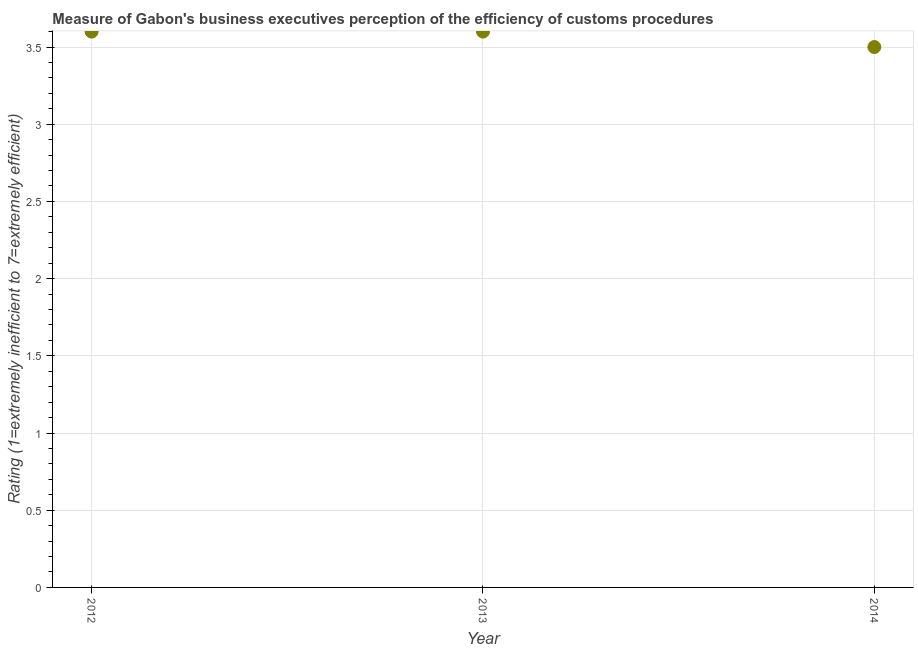Across all years, what is the minimum rating measuring burden of customs procedure?
Keep it short and to the point. 3.5. What is the sum of the rating measuring burden of customs procedure?
Keep it short and to the point. 10.7. What is the difference between the rating measuring burden of customs procedure in 2013 and 2014?
Provide a succinct answer. 0.1. What is the average rating measuring burden of customs procedure per year?
Provide a short and direct response. 3.57. What is the median rating measuring burden of customs procedure?
Give a very brief answer. 3.6. What is the ratio of the rating measuring burden of customs procedure in 2013 to that in 2014?
Your answer should be very brief. 1.03. Is the difference between the rating measuring burden of customs procedure in 2012 and 2014 greater than the difference between any two years?
Your answer should be compact. Yes. What is the difference between the highest and the lowest rating measuring burden of customs procedure?
Make the answer very short. 0.1. In how many years, is the rating measuring burden of customs procedure greater than the average rating measuring burden of customs procedure taken over all years?
Your answer should be compact. 2. Does the rating measuring burden of customs procedure monotonically increase over the years?
Offer a terse response. No. How many dotlines are there?
Offer a very short reply. 1. What is the difference between two consecutive major ticks on the Y-axis?
Provide a short and direct response. 0.5. Does the graph contain any zero values?
Your response must be concise. No. What is the title of the graph?
Offer a terse response. Measure of Gabon's business executives perception of the efficiency of customs procedures. What is the label or title of the Y-axis?
Provide a short and direct response. Rating (1=extremely inefficient to 7=extremely efficient). What is the Rating (1=extremely inefficient to 7=extremely efficient) in 2012?
Your answer should be compact. 3.6. What is the difference between the Rating (1=extremely inefficient to 7=extremely efficient) in 2012 and 2013?
Offer a terse response. 0. What is the difference between the Rating (1=extremely inefficient to 7=extremely efficient) in 2012 and 2014?
Offer a very short reply. 0.1. What is the ratio of the Rating (1=extremely inefficient to 7=extremely efficient) in 2012 to that in 2013?
Give a very brief answer. 1. 